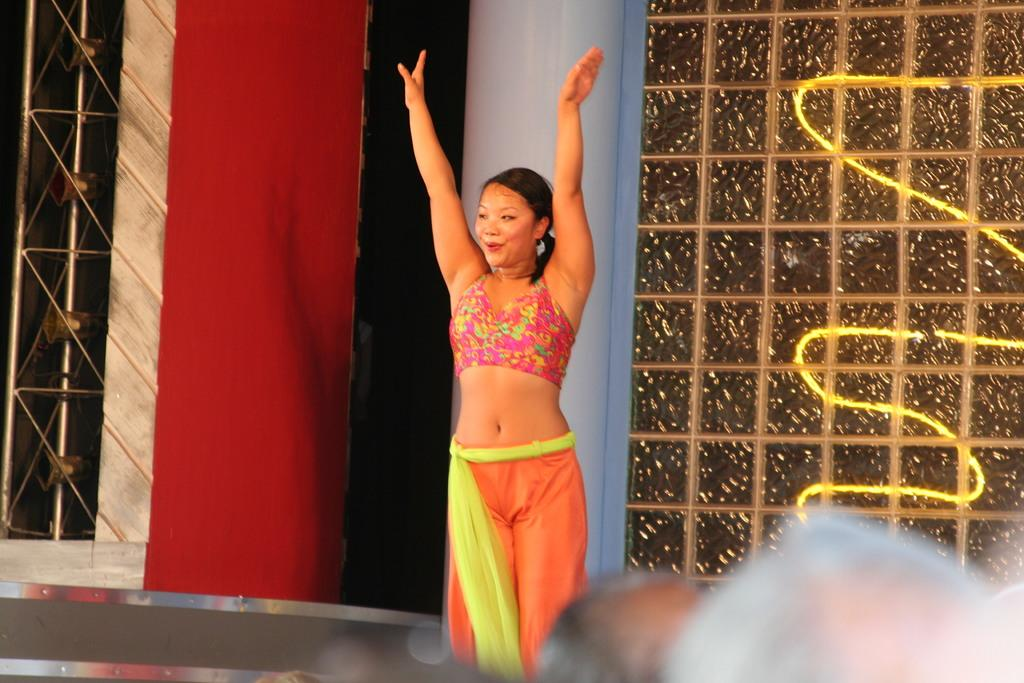Who is the main subject in the image? There is a woman in the middle of the image. What is the woman wearing? The woman is wearing a dress. What is the woman doing in the image? The woman is dancing. Can you describe the people at the bottom of the image? There are people at the bottom of the image, but their actions or appearance are not specified. What can be seen in the background of the image? There is a stage and lights in the background of the image. What type of squirrel can be seen climbing the woman's dress in the image? There is no squirrel present in the image; the woman is simply dancing in a dress. How many eyes does the laborer have in the image? There is no laborer present in the image, so it is not possible to determine the number of eyes they might have. 